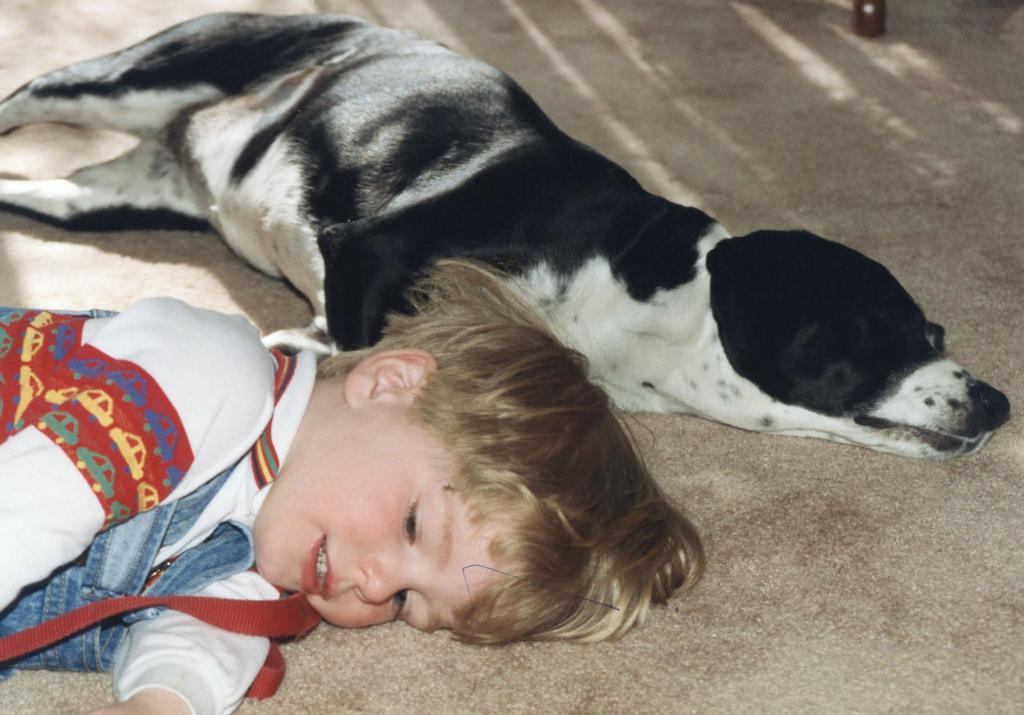Who or what is the main subject in the image? There is a boy in the image. What other living creature is present in the image? There is a dog in the image. What is the dog doing in the image? The dog is lying on the floor. What color pattern does the dog have? The dog is black and white in color. What sound can be heard coming from the dog in the image? There is no sound present in the image, so it's not possible to determine what, if any, sound might be heard. 